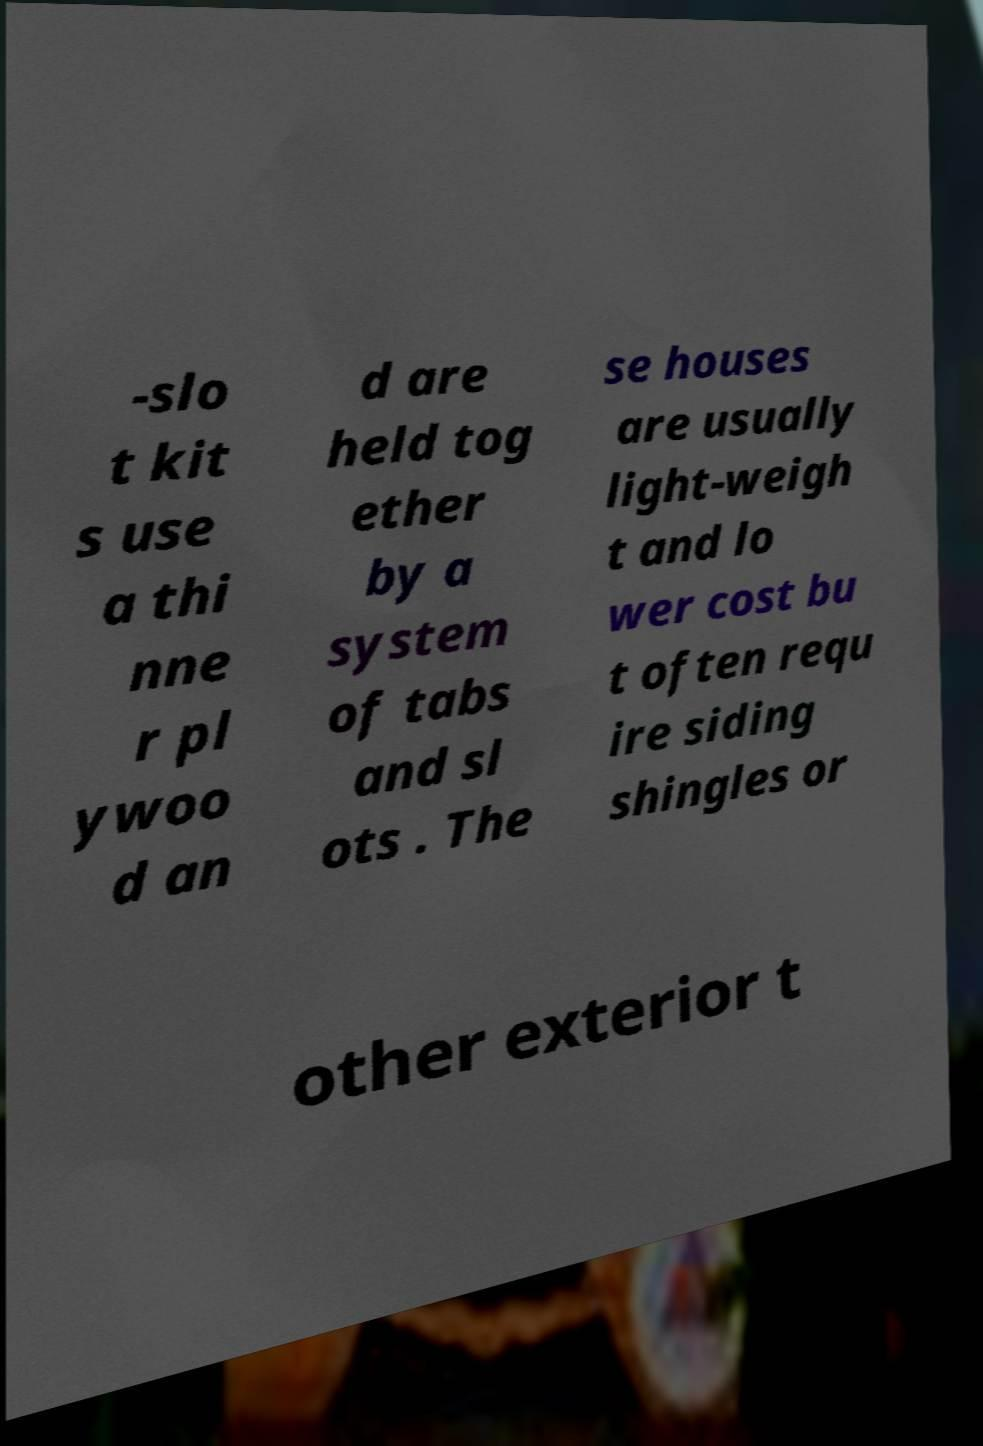Could you extract and type out the text from this image? -slo t kit s use a thi nne r pl ywoo d an d are held tog ether by a system of tabs and sl ots . The se houses are usually light-weigh t and lo wer cost bu t often requ ire siding shingles or other exterior t 